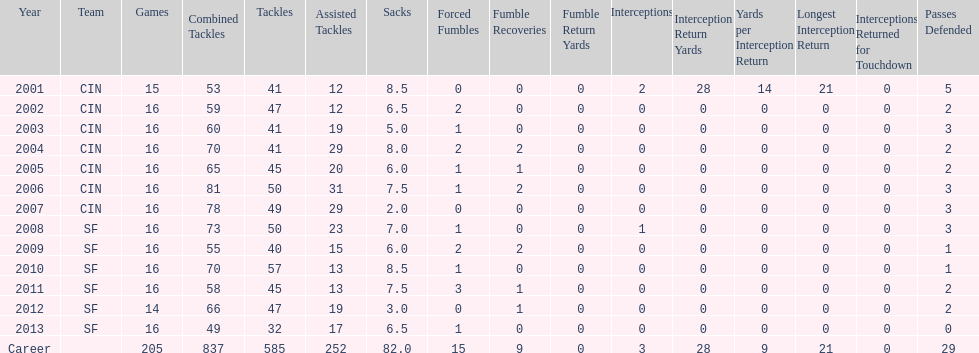Would you mind parsing the complete table? {'header': ['Year', 'Team', 'Games', 'Combined Tackles', 'Tackles', 'Assisted Tackles', 'Sacks', 'Forced Fumbles', 'Fumble Recoveries', 'Fumble Return Yards', 'Interceptions', 'Interception Return Yards', 'Yards per Interception Return', 'Longest Interception Return', 'Interceptions Returned for Touchdown', 'Passes Defended'], 'rows': [['2001', 'CIN', '15', '53', '41', '12', '8.5', '0', '0', '0', '2', '28', '14', '21', '0', '5'], ['2002', 'CIN', '16', '59', '47', '12', '6.5', '2', '0', '0', '0', '0', '0', '0', '0', '2'], ['2003', 'CIN', '16', '60', '41', '19', '5.0', '1', '0', '0', '0', '0', '0', '0', '0', '3'], ['2004', 'CIN', '16', '70', '41', '29', '8.0', '2', '2', '0', '0', '0', '0', '0', '0', '2'], ['2005', 'CIN', '16', '65', '45', '20', '6.0', '1', '1', '0', '0', '0', '0', '0', '0', '2'], ['2006', 'CIN', '16', '81', '50', '31', '7.5', '1', '2', '0', '0', '0', '0', '0', '0', '3'], ['2007', 'CIN', '16', '78', '49', '29', '2.0', '0', '0', '0', '0', '0', '0', '0', '0', '3'], ['2008', 'SF', '16', '73', '50', '23', '7.0', '1', '0', '0', '1', '0', '0', '0', '0', '3'], ['2009', 'SF', '16', '55', '40', '15', '6.0', '2', '2', '0', '0', '0', '0', '0', '0', '1'], ['2010', 'SF', '16', '70', '57', '13', '8.5', '1', '0', '0', '0', '0', '0', '0', '0', '1'], ['2011', 'SF', '16', '58', '45', '13', '7.5', '3', '1', '0', '0', '0', '0', '0', '0', '2'], ['2012', 'SF', '14', '66', '47', '19', '3.0', '0', '1', '0', '0', '0', '0', '0', '0', '2'], ['2013', 'SF', '16', '49', '32', '17', '6.5', '1', '0', '0', '0', '0', '0', '0', '0', '0'], ['Career', '', '205', '837', '585', '252', '82.0', '15', '9', '0', '3', '28', '9', '21', '0', '29']]} In 2004, how many fumble recoveries were made by this player? 2. 